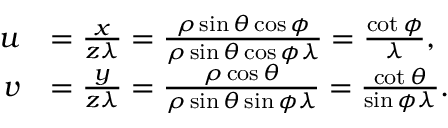<formula> <loc_0><loc_0><loc_500><loc_500>\begin{array} { r l } { u } & { = \frac { x } { z \lambda } = \frac { \rho \sin { \theta } \cos { \phi } } { \rho \sin { \theta } \cos { \phi } \lambda } = \frac { \cot { \phi } } { \lambda } , } \\ { v } & { = \frac { y } { z \lambda } = \frac { \rho \cos { \theta } } { \rho \sin { \theta } \sin { \phi } \lambda } = \frac { \cot { \theta } } { \sin { \phi } \lambda } . } \end{array}</formula> 